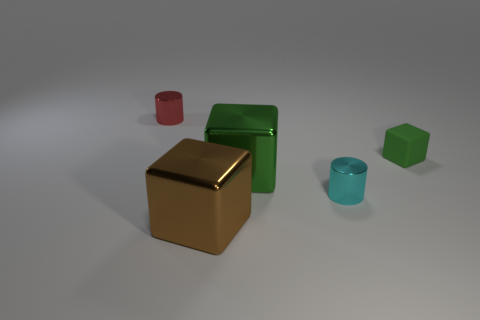Add 2 brown blocks. How many objects exist? 7 Subtract all blocks. How many objects are left? 2 Subtract all cyan objects. Subtract all cubes. How many objects are left? 1 Add 3 large brown things. How many large brown things are left? 4 Add 2 tiny red things. How many tiny red things exist? 3 Subtract 0 yellow balls. How many objects are left? 5 